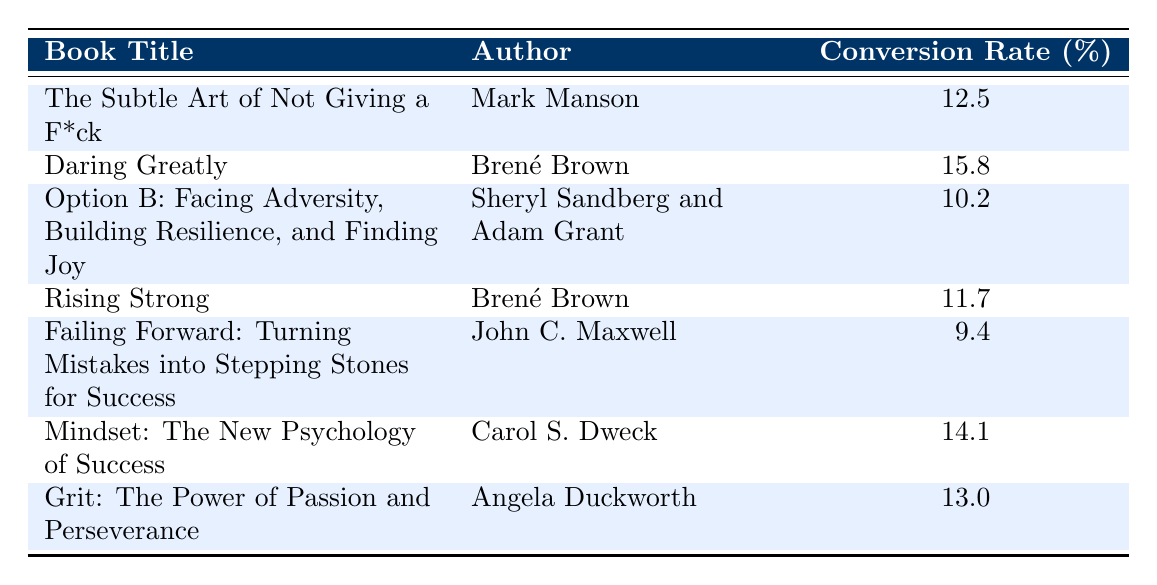What is the highest sales conversion rate among the listed books? The highest sales conversion rate is identified by comparing the values in the "Conversion Rate" column. The highest value is 15.8, which belongs to "Daring Greatly" by Brené Brown.
Answer: 15.8 Which author has the most books listed in the table? By scanning through the "Author" column, we can see that Brené Brown appears twice (for "Daring Greatly" and "Rising Strong"), while other authors appear only once. Therefore, Brené Brown has the most books listed.
Answer: Brené Brown What is the average sales conversion rate of the books in this table? To find the average, sum all conversion rates: (12.5 + 15.8 + 10.2 + 11.7 + 9.4 + 14.1 + 13.0) = 96.7. Since there are 7 books, we divide the total by 7: 96.7 / 7 = 13.1.
Answer: 13.1 Is the sales conversion rate of "Mindset: The New Psychology of Success" higher than that of "Rising Strong"? Checking the respective conversion rates, "Mindset" has a rate of 14.1 and "Rising Strong" has 11.7. Since 14.1 is greater than 11.7, the statement is true.
Answer: Yes What is the difference in sales conversion rates between "Grit: The Power of Passion and Perseverance" and "Failing Forward: Turning Mistakes into Stepping Stones for Success"? The conversion rate for "Grit" is 13.0 and for "Failing Forward" is 9.4. The difference is 13.0 - 9.4 = 3.6. This illustrates how much higher "Grit" performs compared to "Failing Forward".
Answer: 3.6 Did any of the books have a sales conversion rate below 10%? By looking at the conversion rates, "Failing Forward: Turning Mistakes into Stepping Stones for Success" has a conversion rate of 9.4, which is below 10%. Therefore, this statement is true.
Answer: Yes Which book has the lowest sales conversion rate, and what is that rate? The lowest conversion rate can be found by examining all the rates, where "Failing Forward" at 9.4 is the lowest. Thus, the book with the lowest rate is identified.
Answer: Failing Forward: 9.4 What is the combined sales conversion rate of the two books by Brené Brown? For "Daring Greatly" the conversion rate is 15.8, and for "Rising Strong" it is 11.7. The sum is 15.8 + 11.7 = 27.5, which shows the collective performance of her books on sales conversion.
Answer: 27.5 